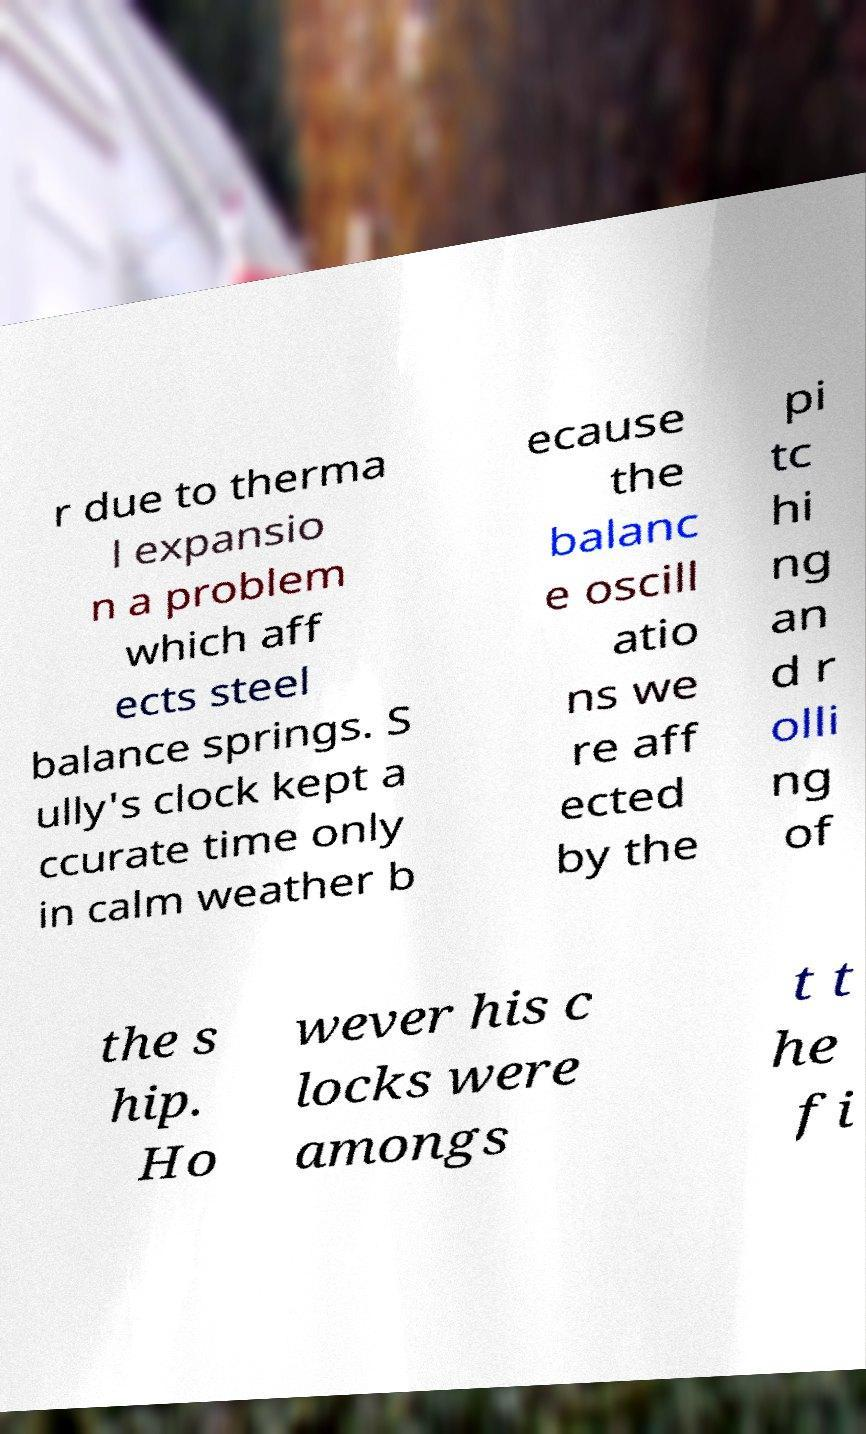Please identify and transcribe the text found in this image. r due to therma l expansio n a problem which aff ects steel balance springs. S ully's clock kept a ccurate time only in calm weather b ecause the balanc e oscill atio ns we re aff ected by the pi tc hi ng an d r olli ng of the s hip. Ho wever his c locks were amongs t t he fi 